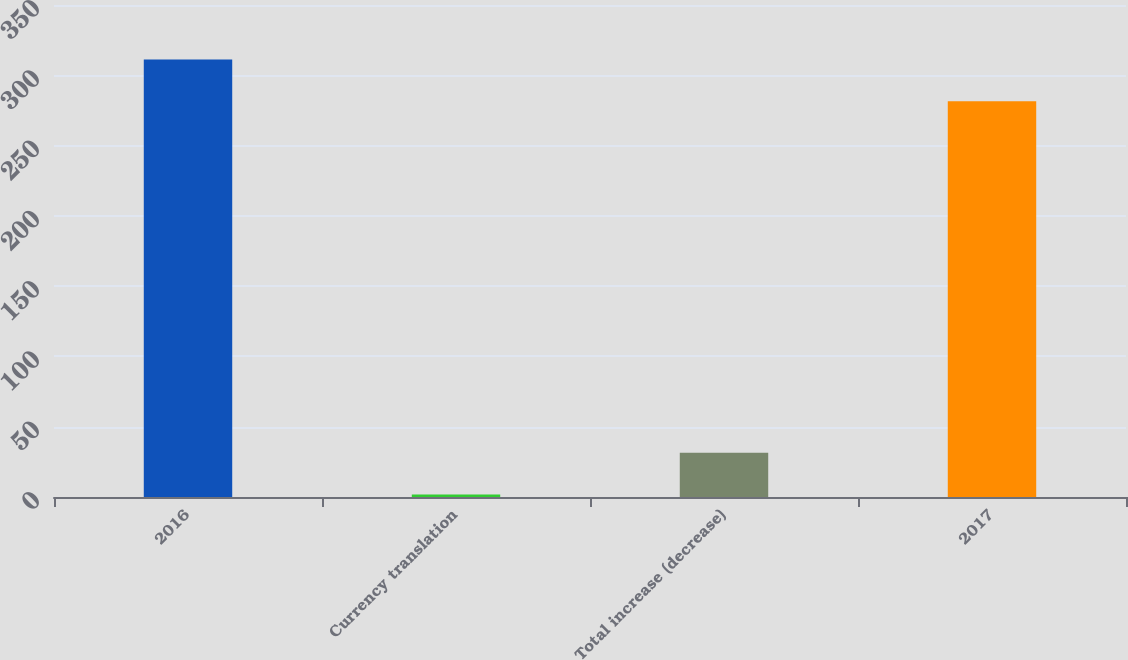Convert chart. <chart><loc_0><loc_0><loc_500><loc_500><bar_chart><fcel>2016<fcel>Currency translation<fcel>Total increase (decrease)<fcel>2017<nl><fcel>311.23<fcel>1.7<fcel>31.43<fcel>281.5<nl></chart> 